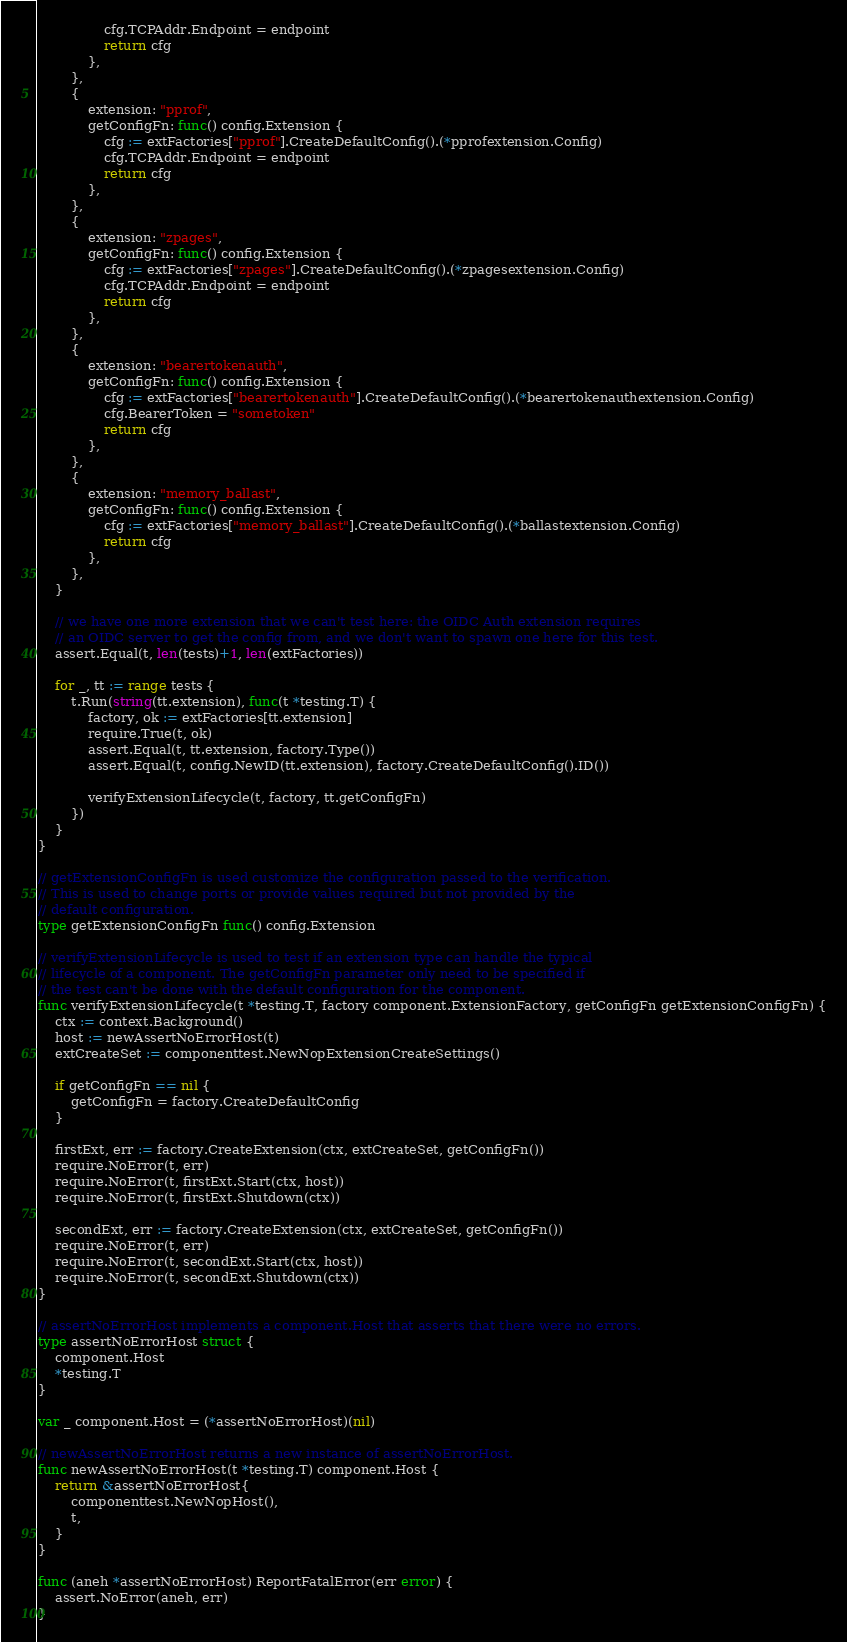<code> <loc_0><loc_0><loc_500><loc_500><_Go_>				cfg.TCPAddr.Endpoint = endpoint
				return cfg
			},
		},
		{
			extension: "pprof",
			getConfigFn: func() config.Extension {
				cfg := extFactories["pprof"].CreateDefaultConfig().(*pprofextension.Config)
				cfg.TCPAddr.Endpoint = endpoint
				return cfg
			},
		},
		{
			extension: "zpages",
			getConfigFn: func() config.Extension {
				cfg := extFactories["zpages"].CreateDefaultConfig().(*zpagesextension.Config)
				cfg.TCPAddr.Endpoint = endpoint
				return cfg
			},
		},
		{
			extension: "bearertokenauth",
			getConfigFn: func() config.Extension {
				cfg := extFactories["bearertokenauth"].CreateDefaultConfig().(*bearertokenauthextension.Config)
				cfg.BearerToken = "sometoken"
				return cfg
			},
		},
		{
			extension: "memory_ballast",
			getConfigFn: func() config.Extension {
				cfg := extFactories["memory_ballast"].CreateDefaultConfig().(*ballastextension.Config)
				return cfg
			},
		},
	}

	// we have one more extension that we can't test here: the OIDC Auth extension requires
	// an OIDC server to get the config from, and we don't want to spawn one here for this test.
	assert.Equal(t, len(tests)+1, len(extFactories))

	for _, tt := range tests {
		t.Run(string(tt.extension), func(t *testing.T) {
			factory, ok := extFactories[tt.extension]
			require.True(t, ok)
			assert.Equal(t, tt.extension, factory.Type())
			assert.Equal(t, config.NewID(tt.extension), factory.CreateDefaultConfig().ID())

			verifyExtensionLifecycle(t, factory, tt.getConfigFn)
		})
	}
}

// getExtensionConfigFn is used customize the configuration passed to the verification.
// This is used to change ports or provide values required but not provided by the
// default configuration.
type getExtensionConfigFn func() config.Extension

// verifyExtensionLifecycle is used to test if an extension type can handle the typical
// lifecycle of a component. The getConfigFn parameter only need to be specified if
// the test can't be done with the default configuration for the component.
func verifyExtensionLifecycle(t *testing.T, factory component.ExtensionFactory, getConfigFn getExtensionConfigFn) {
	ctx := context.Background()
	host := newAssertNoErrorHost(t)
	extCreateSet := componenttest.NewNopExtensionCreateSettings()

	if getConfigFn == nil {
		getConfigFn = factory.CreateDefaultConfig
	}

	firstExt, err := factory.CreateExtension(ctx, extCreateSet, getConfigFn())
	require.NoError(t, err)
	require.NoError(t, firstExt.Start(ctx, host))
	require.NoError(t, firstExt.Shutdown(ctx))

	secondExt, err := factory.CreateExtension(ctx, extCreateSet, getConfigFn())
	require.NoError(t, err)
	require.NoError(t, secondExt.Start(ctx, host))
	require.NoError(t, secondExt.Shutdown(ctx))
}

// assertNoErrorHost implements a component.Host that asserts that there were no errors.
type assertNoErrorHost struct {
	component.Host
	*testing.T
}

var _ component.Host = (*assertNoErrorHost)(nil)

// newAssertNoErrorHost returns a new instance of assertNoErrorHost.
func newAssertNoErrorHost(t *testing.T) component.Host {
	return &assertNoErrorHost{
		componenttest.NewNopHost(),
		t,
	}
}

func (aneh *assertNoErrorHost) ReportFatalError(err error) {
	assert.NoError(aneh, err)
}
</code> 